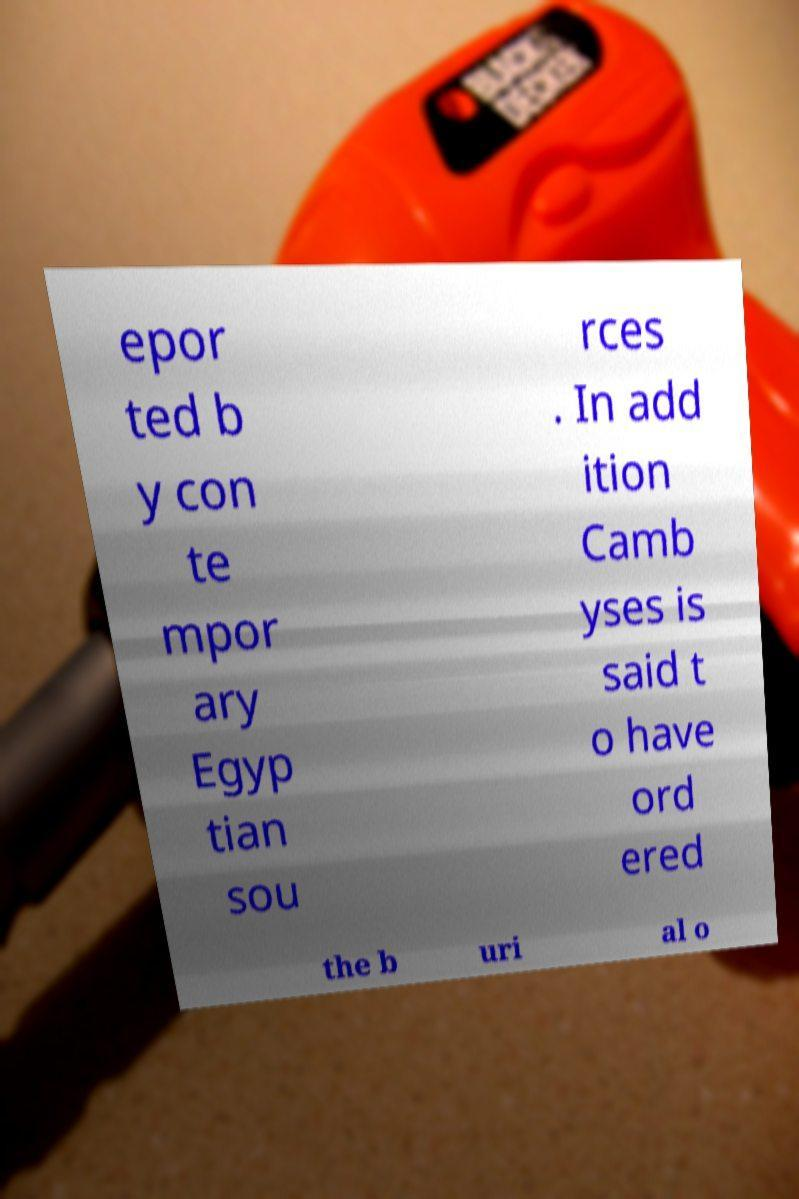Can you accurately transcribe the text from the provided image for me? epor ted b y con te mpor ary Egyp tian sou rces . In add ition Camb yses is said t o have ord ered the b uri al o 